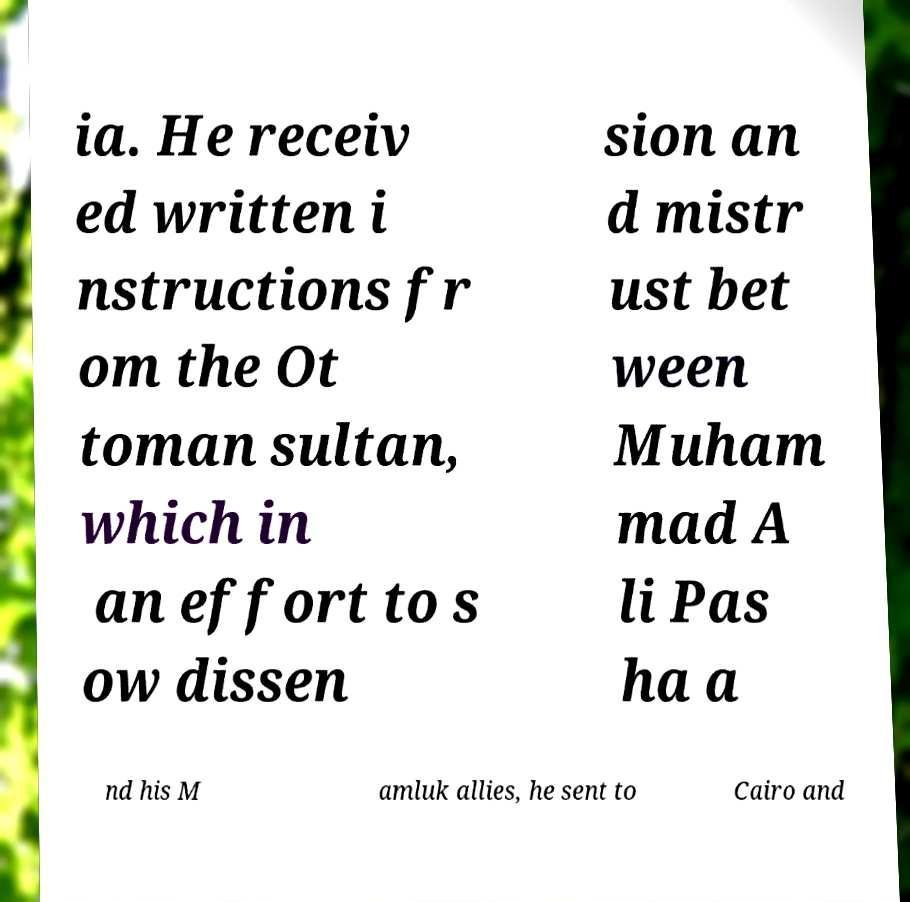Could you extract and type out the text from this image? ia. He receiv ed written i nstructions fr om the Ot toman sultan, which in an effort to s ow dissen sion an d mistr ust bet ween Muham mad A li Pas ha a nd his M amluk allies, he sent to Cairo and 